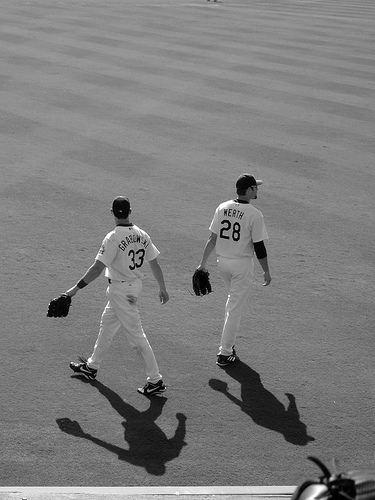How many people are in the photo? 2 